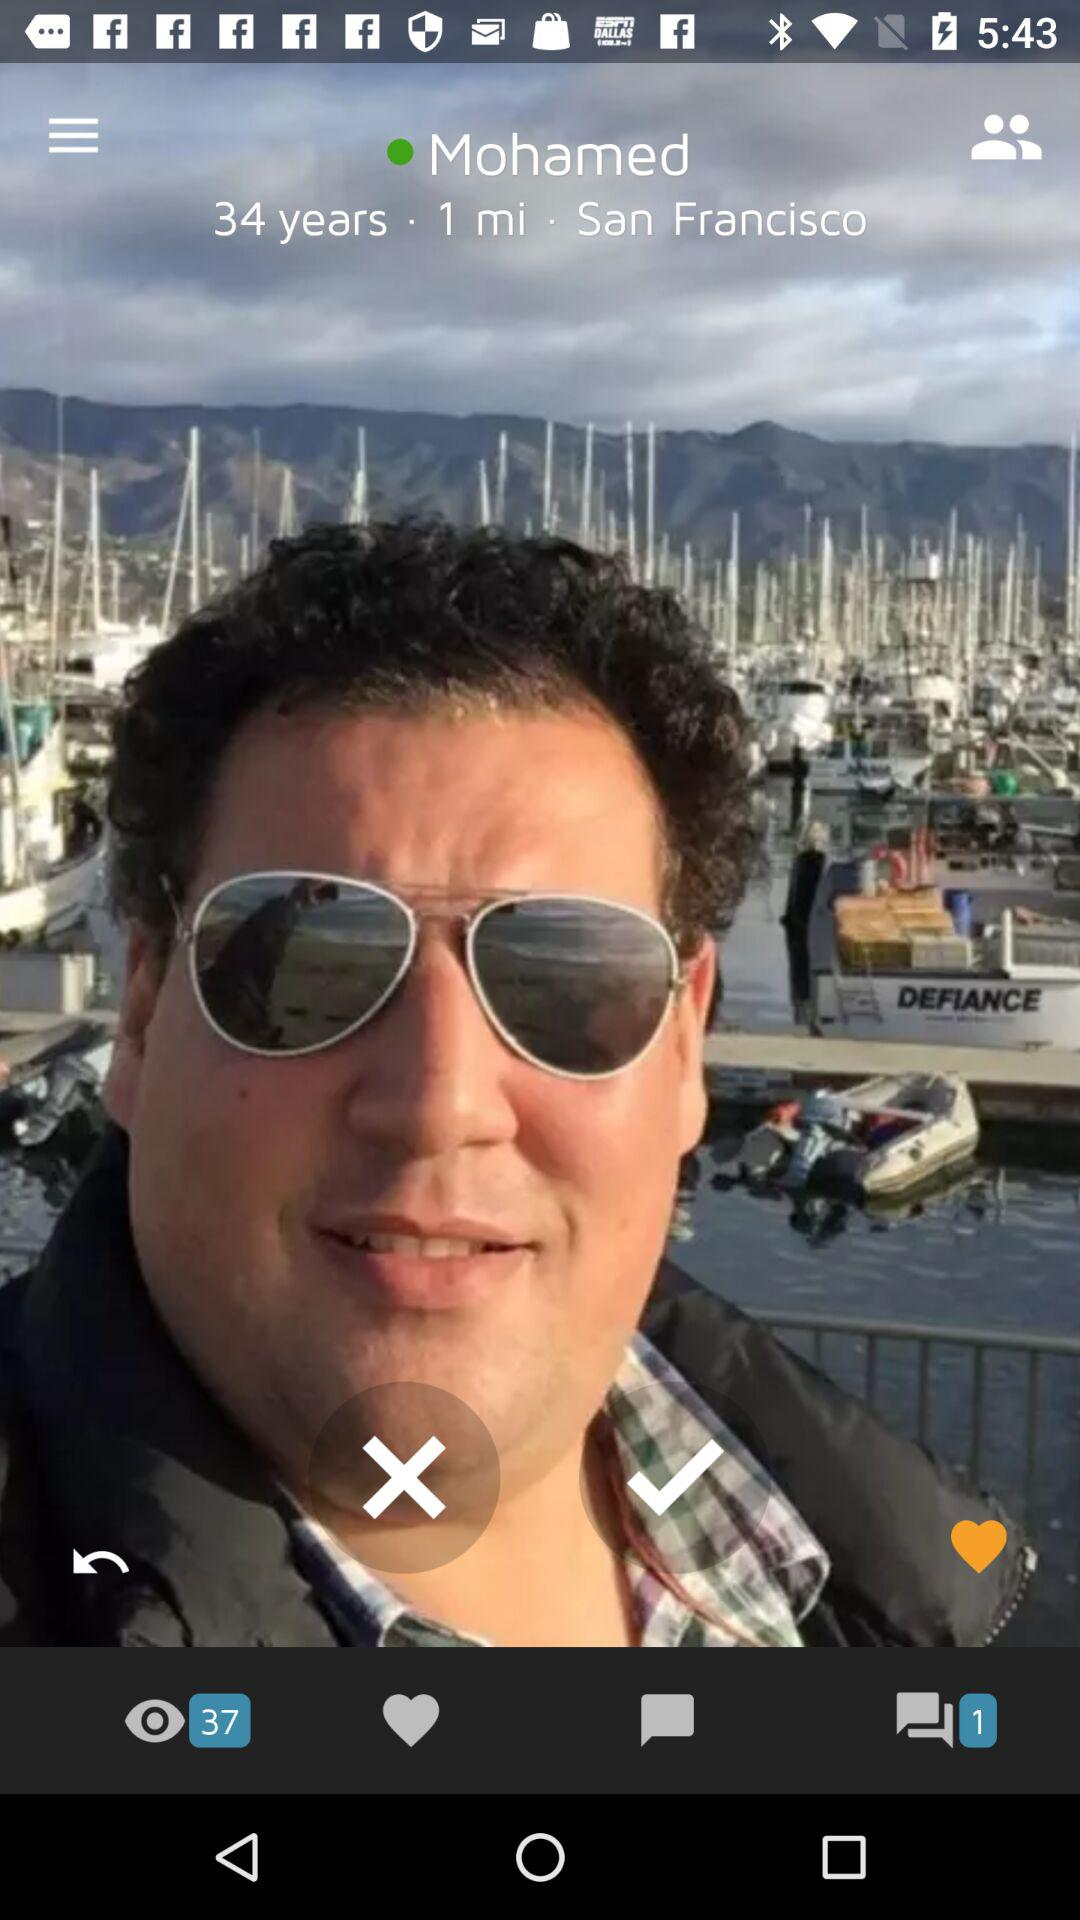What is the name of the person? The name of the person is Mohamed. 